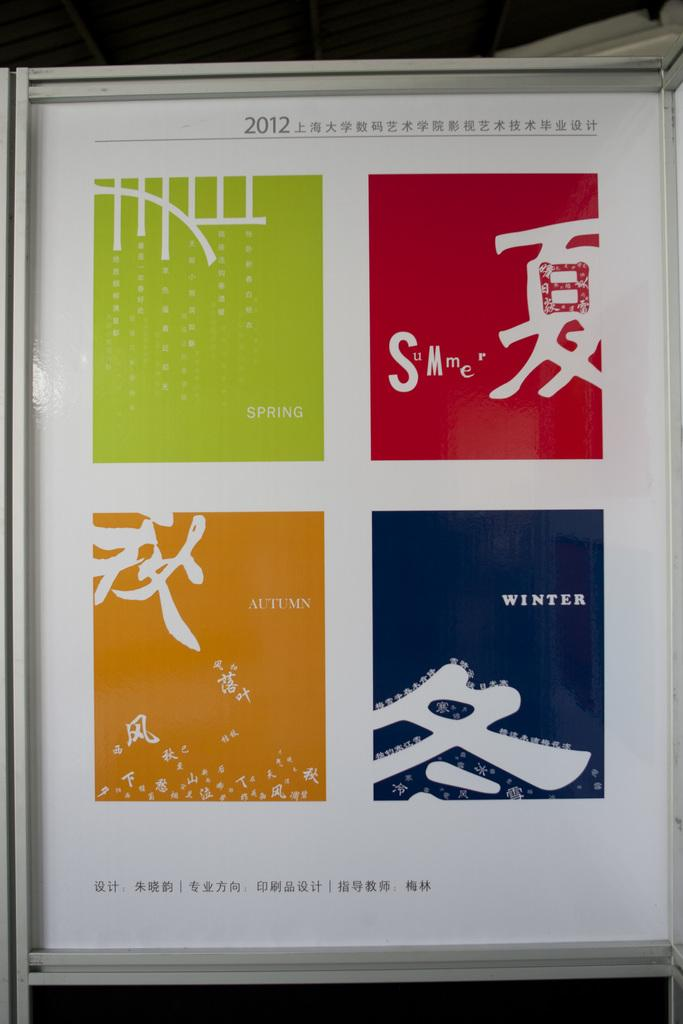Provide a one-sentence caption for the provided image. A bookcover with Spring, Summer, Autumn, and Winter in colored squares. 